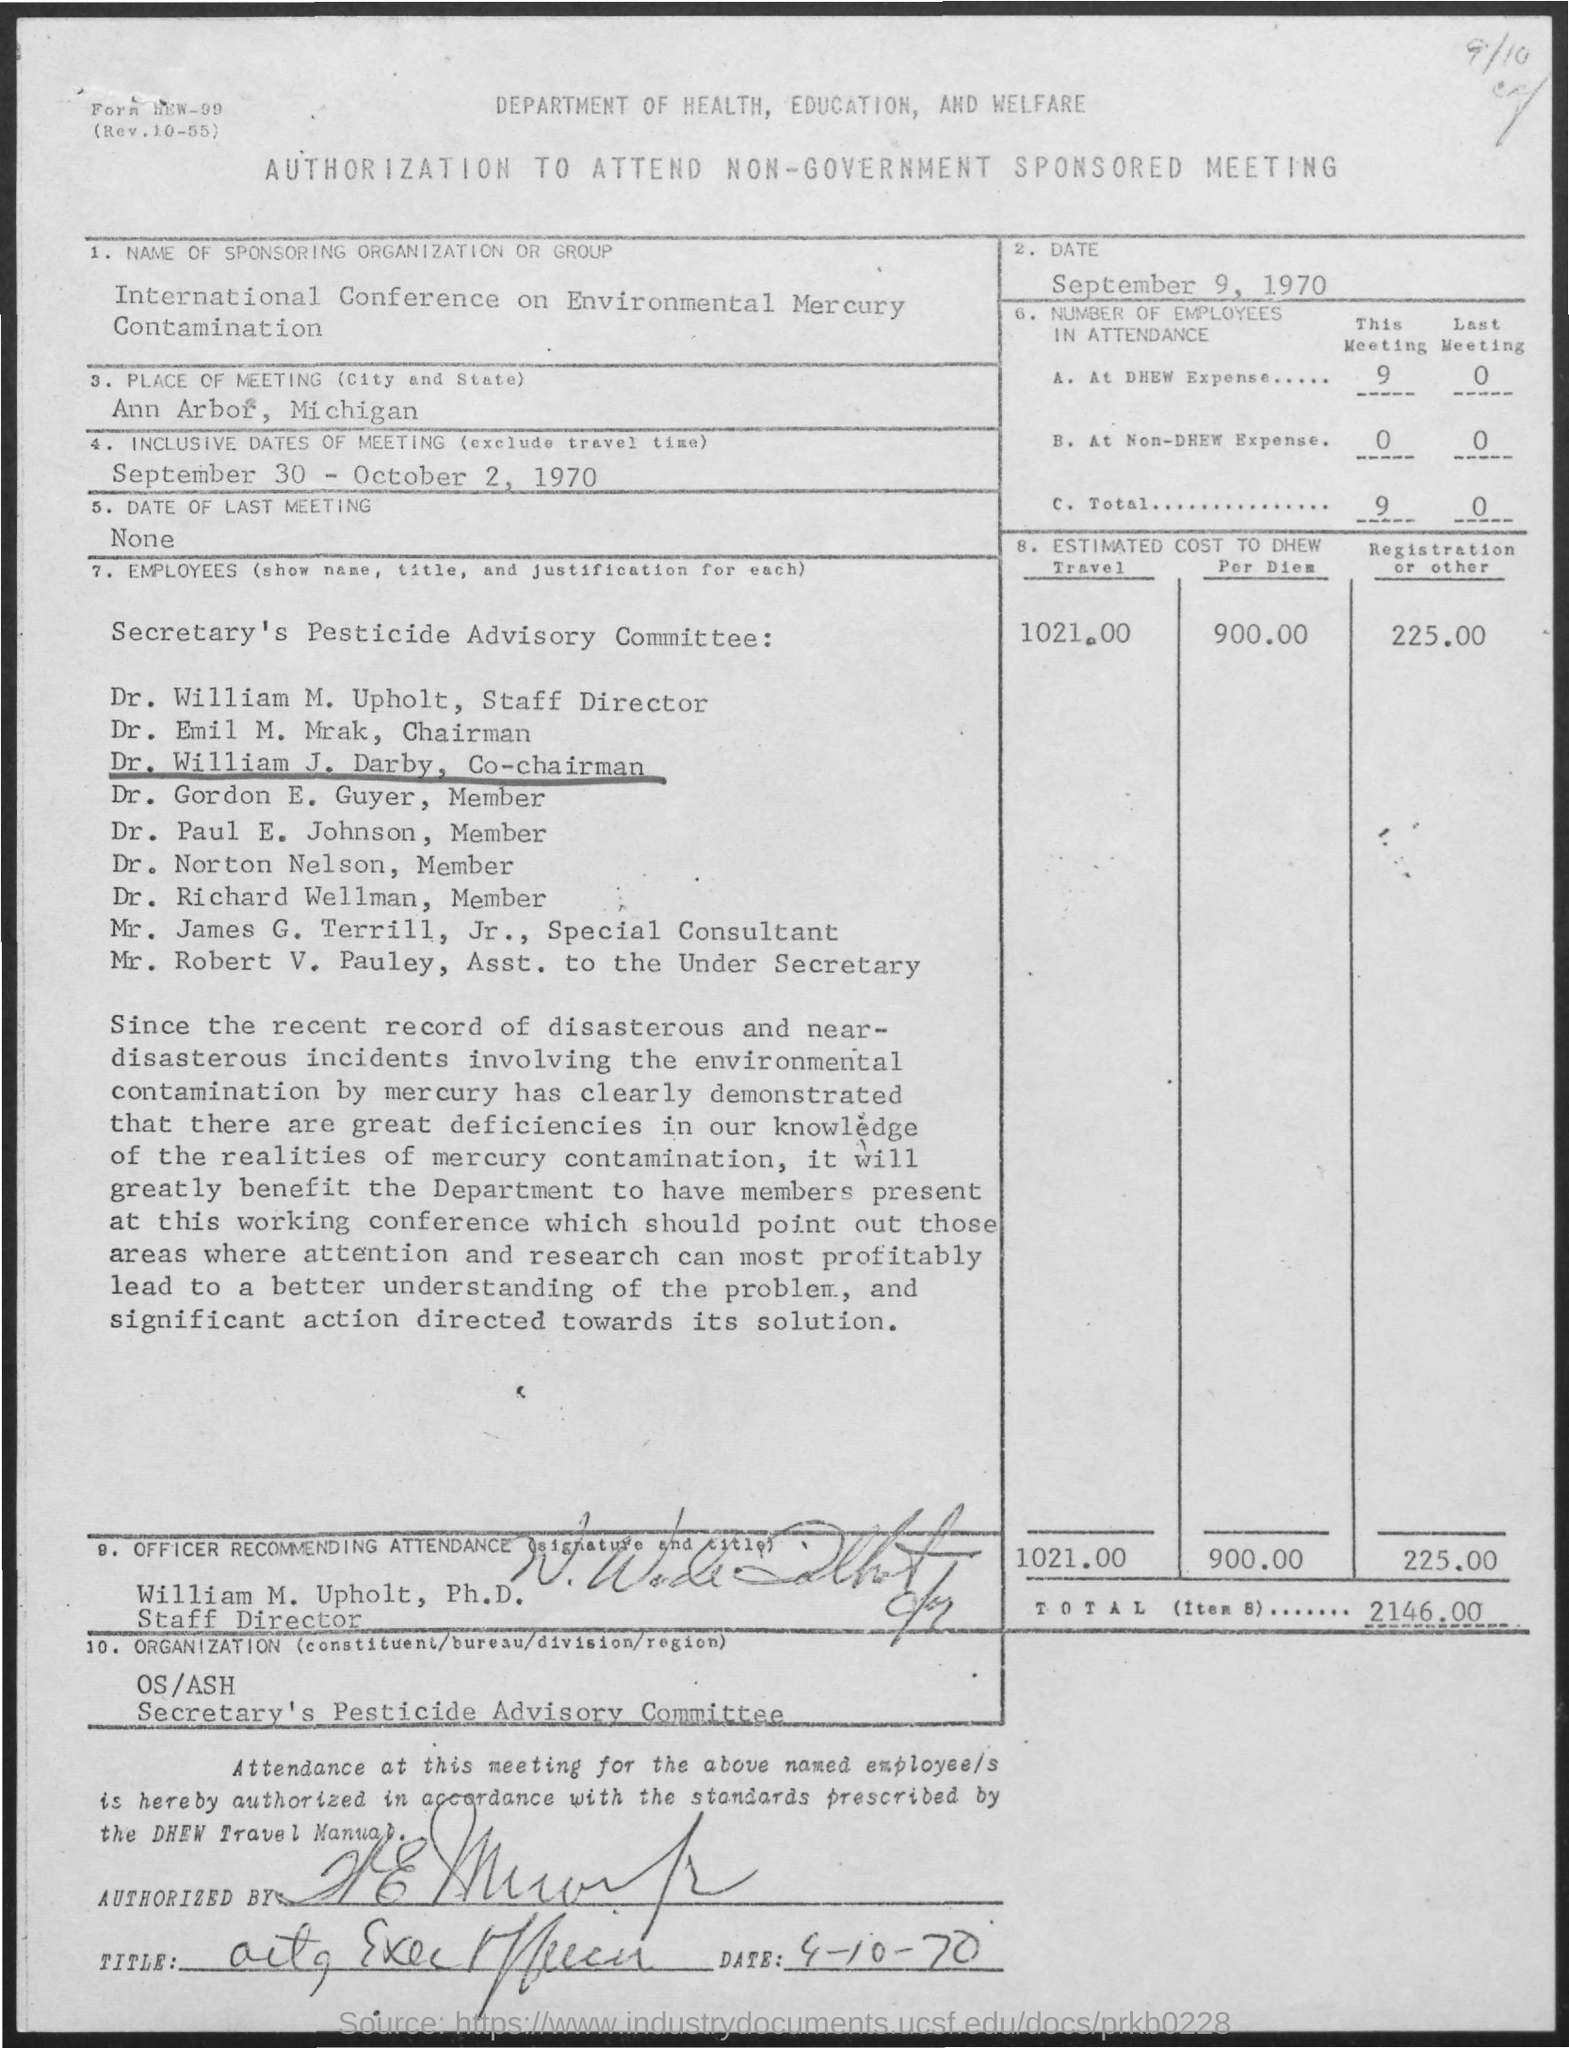Give some essential details in this illustration. The place of the meeting is Ann Arbor, Michigan. The number of employees in attendance at the DHEW Expense meeting is 9. The inclusive dates of the meeting are September 30th through October 2nd, 1970. To my knowledge, there has not been a meeting held in the past. The estimated cost for DHEW (Department of Health, Education, and Welfare) for travel is 1021.00. 